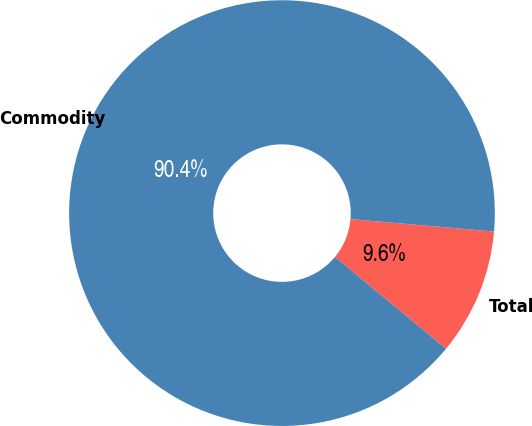Convert chart to OTSL. <chart><loc_0><loc_0><loc_500><loc_500><pie_chart><fcel>Total<fcel>Commodity<nl><fcel>9.62%<fcel>90.38%<nl></chart> 